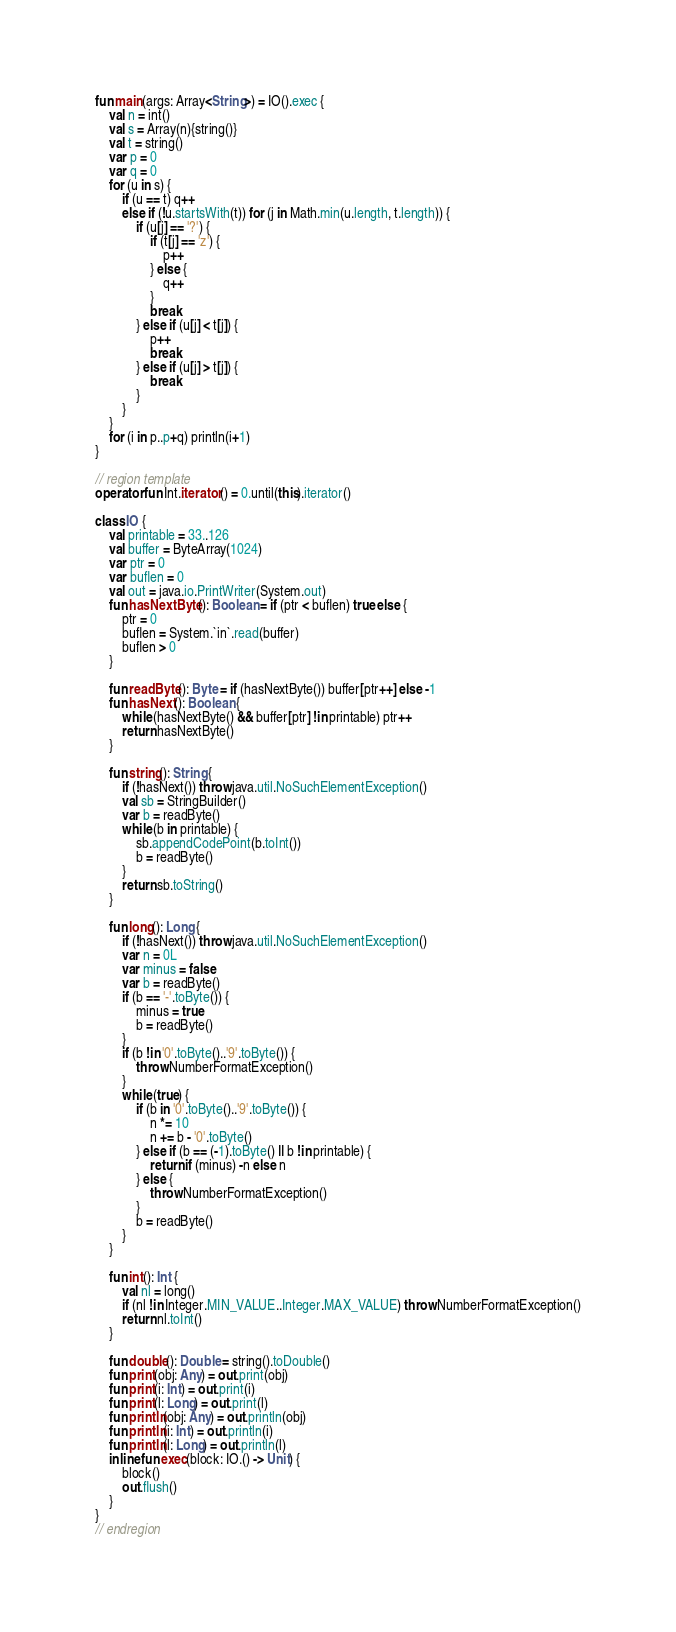<code> <loc_0><loc_0><loc_500><loc_500><_Kotlin_>fun main(args: Array<String>) = IO().exec {
    val n = int()
    val s = Array(n){string()}
    val t = string()
    var p = 0
    var q = 0
    for (u in s) {
        if (u == t) q++
        else if (!u.startsWith(t)) for (j in Math.min(u.length, t.length)) {
            if (u[j] == '?') {
                if (t[j] == 'z') {
                    p++
                } else {
                    q++
                }
                break
            } else if (u[j] < t[j]) {
                p++
                break
            } else if (u[j] > t[j]) {
                break
            }
        }
    }
    for (i in p..p+q) println(i+1)
}

// region template
operator fun Int.iterator() = 0.until(this).iterator()

class IO {
    val printable = 33..126
    val buffer = ByteArray(1024)
    var ptr = 0
    var buflen = 0
    val out = java.io.PrintWriter(System.out)
    fun hasNextByte(): Boolean = if (ptr < buflen) true else {
        ptr = 0
        buflen = System.`in`.read(buffer)
        buflen > 0
    }

    fun readByte(): Byte = if (hasNextByte()) buffer[ptr++] else -1
    fun hasNext(): Boolean {
        while (hasNextByte() && buffer[ptr] !in printable) ptr++
        return hasNextByte()
    }

    fun string(): String {
        if (!hasNext()) throw java.util.NoSuchElementException()
        val sb = StringBuilder()
        var b = readByte()
        while (b in printable) {
            sb.appendCodePoint(b.toInt())
            b = readByte()
        }
        return sb.toString()
    }

    fun long(): Long {
        if (!hasNext()) throw java.util.NoSuchElementException()
        var n = 0L
        var minus = false
        var b = readByte()
        if (b == '-'.toByte()) {
            minus = true
            b = readByte()
        }
        if (b !in '0'.toByte()..'9'.toByte()) {
            throw NumberFormatException()
        }
        while (true) {
            if (b in '0'.toByte()..'9'.toByte()) {
                n *= 10
                n += b - '0'.toByte()
            } else if (b == (-1).toByte() || b !in printable) {
                return if (minus) -n else n
            } else {
                throw NumberFormatException()
            }
            b = readByte()
        }
    }

    fun int(): Int {
        val nl = long()
        if (nl !in Integer.MIN_VALUE..Integer.MAX_VALUE) throw NumberFormatException()
        return nl.toInt()
    }

    fun double(): Double = string().toDouble()
    fun print(obj: Any) = out.print(obj)
    fun print(i: Int) = out.print(i)
    fun print(l: Long) = out.print(l)
    fun println(obj: Any) = out.println(obj)
    fun println(i: Int) = out.println(i)
    fun println(l: Long) = out.println(l)
    inline fun exec(block: IO.() -> Unit) {
        block()
        out.flush()
    }
}
// endregion</code> 